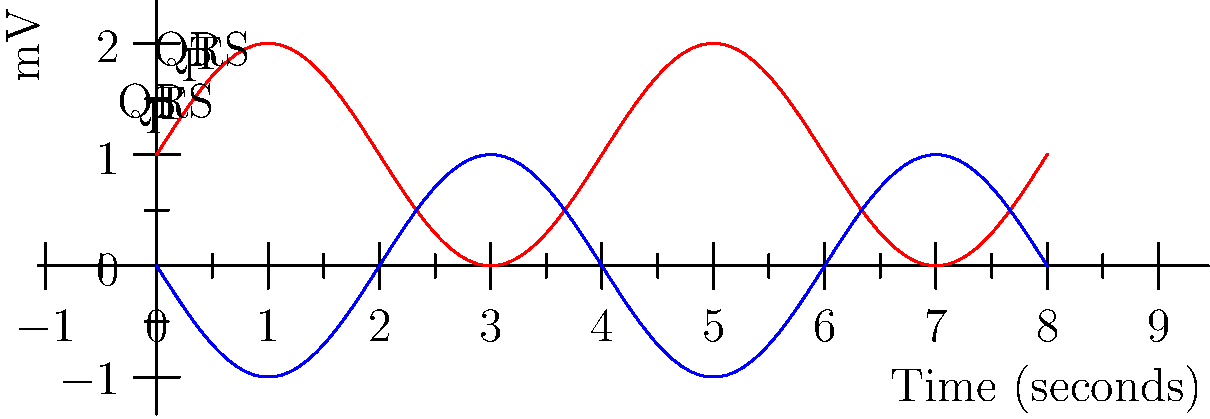Analyze the ECG graph above. What is the heart rate in beats per minute (bpm) based on the R-R interval? To calculate the heart rate from an ECG:

1. Identify the R waves: The tall, positive deflections in the QRS complex.
2. Measure the R-R interval: The distance between two consecutive R waves.
3. Count the number of large squares between R waves: Each large square represents 0.2 seconds.
4. Use the formula: Heart Rate (bpm) = 60 seconds / R-R interval in seconds

From the graph:
1. R waves are at the peaks of the red curve.
2. The R-R interval spans 4 large squares.
3. 4 large squares × 0.2 seconds/square = 0.8 seconds

Therefore:
Heart Rate = 60 seconds / 0.8 seconds = 75 bpm
Answer: 75 bpm 